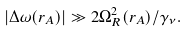Convert formula to latex. <formula><loc_0><loc_0><loc_500><loc_500>| \Delta \omega ( r _ { A } ) | \gg 2 \Omega ^ { 2 } _ { R } ( r _ { A } ) / \gamma _ { \nu } .</formula> 